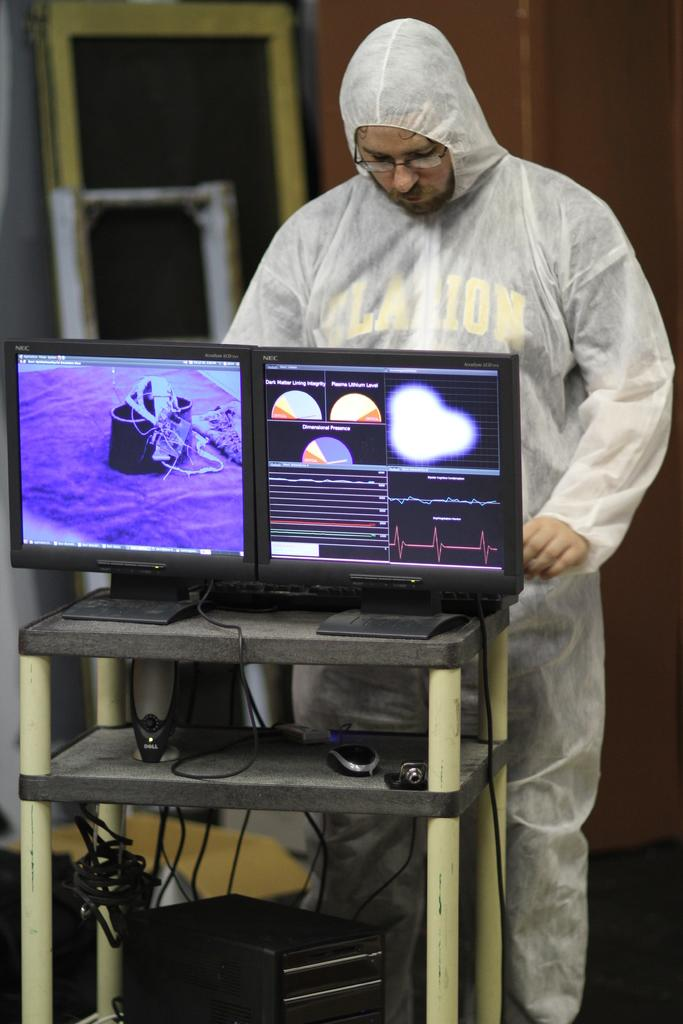What is the man doing in the image? The man is standing on the right side of the image. What object is on the table in the image? There is a computer on a table in the image. Where is the table located in the image? The table is at the bottom of the image. What can be seen in the background of the image? There is a wall in the background of the image. How many drawers are visible in the image? There are no drawers present in the image. Can you see a yak in the image? No, there is no yak present in the image. 